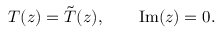Convert formula to latex. <formula><loc_0><loc_0><loc_500><loc_500>T ( z ) = \tilde { T } ( z ) , \quad I m ( z ) = 0 .</formula> 